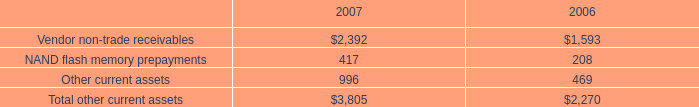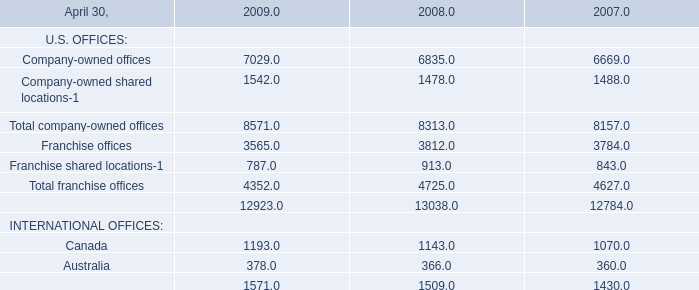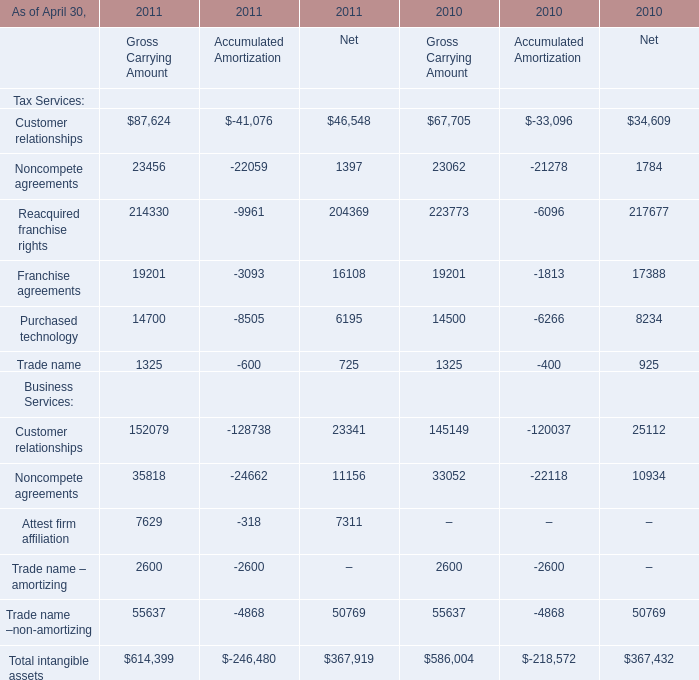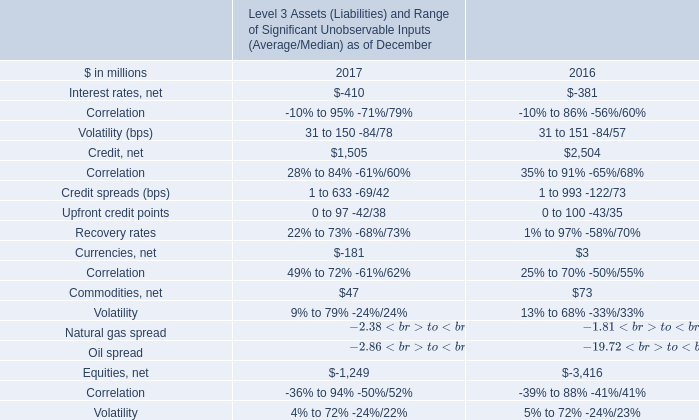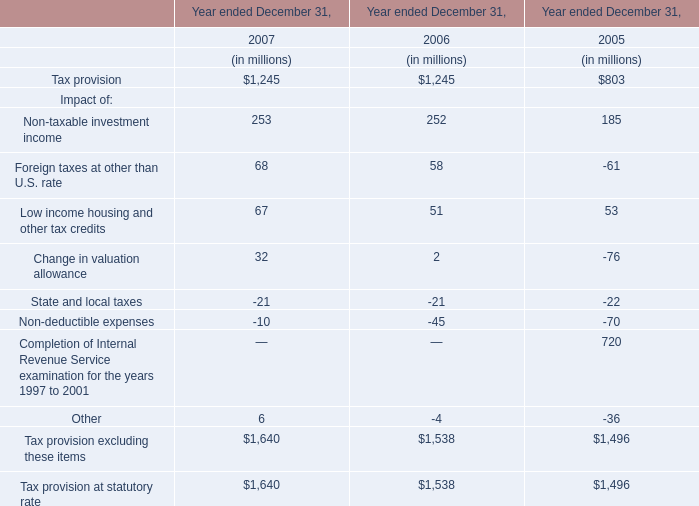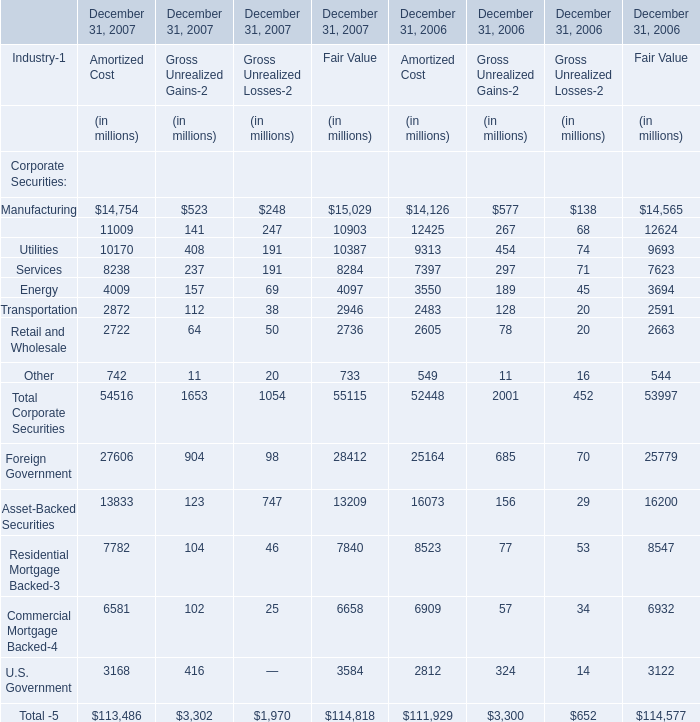What's the growth rate of the value of the Gross Unrealized Gains for Total Corporate Securities on December 31 in 2007? 
Computations: ((1653 - 2001) / 2001)
Answer: -0.17391. 